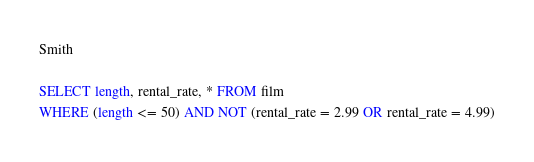Convert code to text. <code><loc_0><loc_0><loc_500><loc_500><_SQL_>
Smith

SELECT length, rental_rate, * FROM film
WHERE (length <= 50) AND NOT (rental_rate = 2.99 OR rental_rate = 4.99)
</code> 